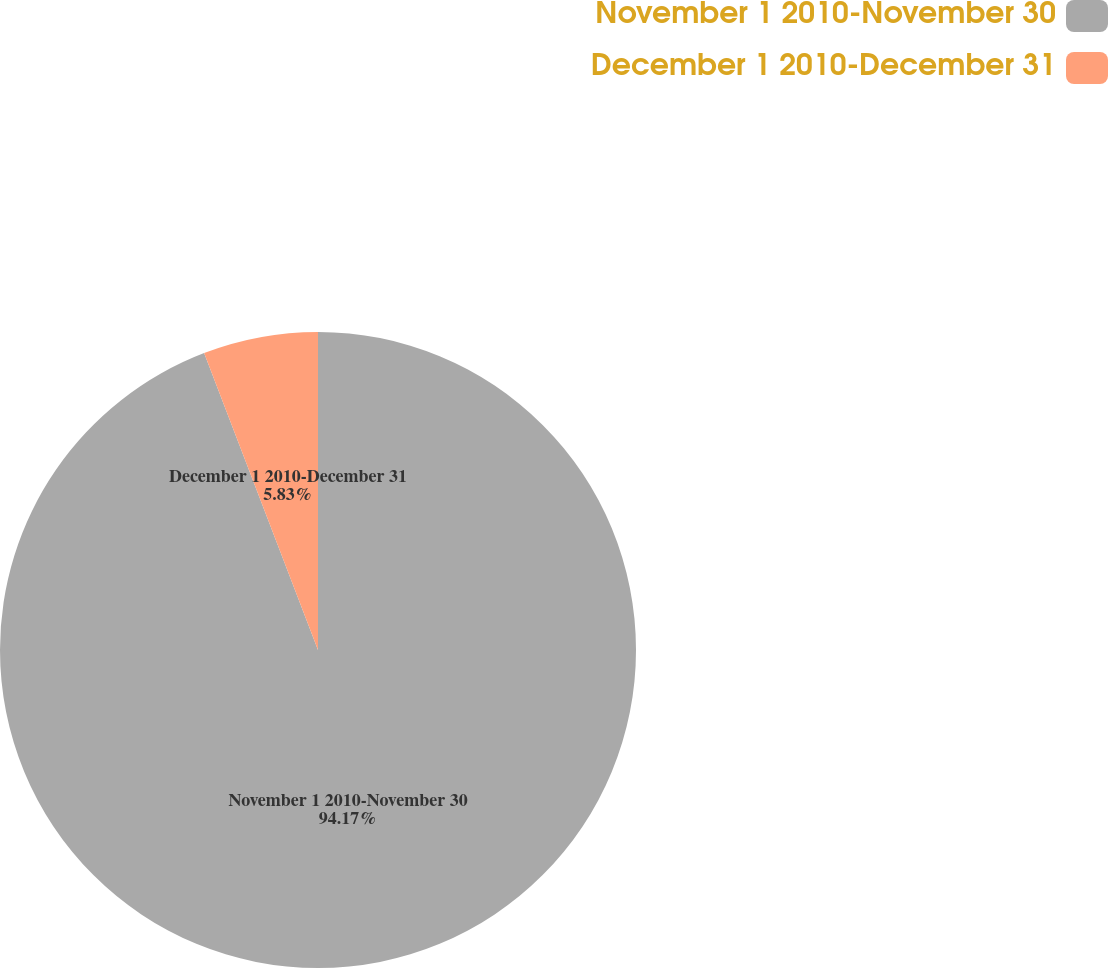Convert chart. <chart><loc_0><loc_0><loc_500><loc_500><pie_chart><fcel>November 1 2010-November 30<fcel>December 1 2010-December 31<nl><fcel>94.17%<fcel>5.83%<nl></chart> 